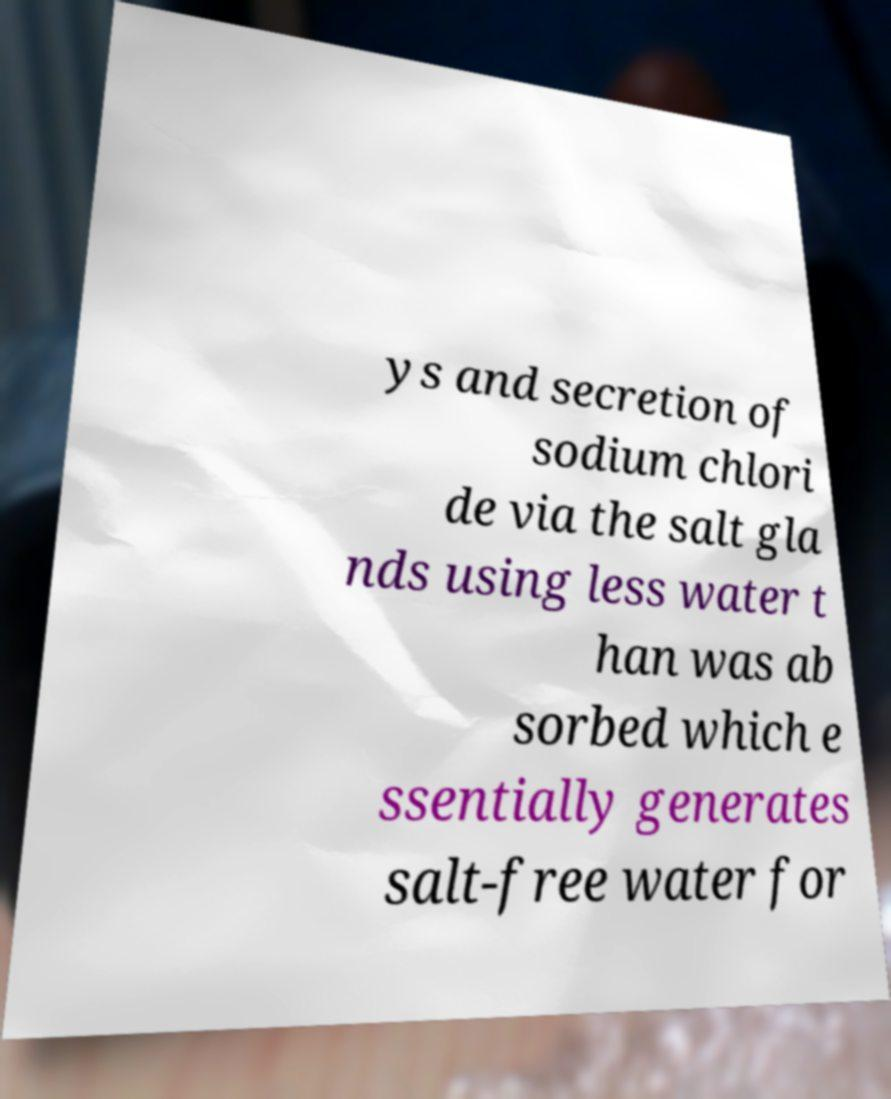I need the written content from this picture converted into text. Can you do that? ys and secretion of sodium chlori de via the salt gla nds using less water t han was ab sorbed which e ssentially generates salt-free water for 